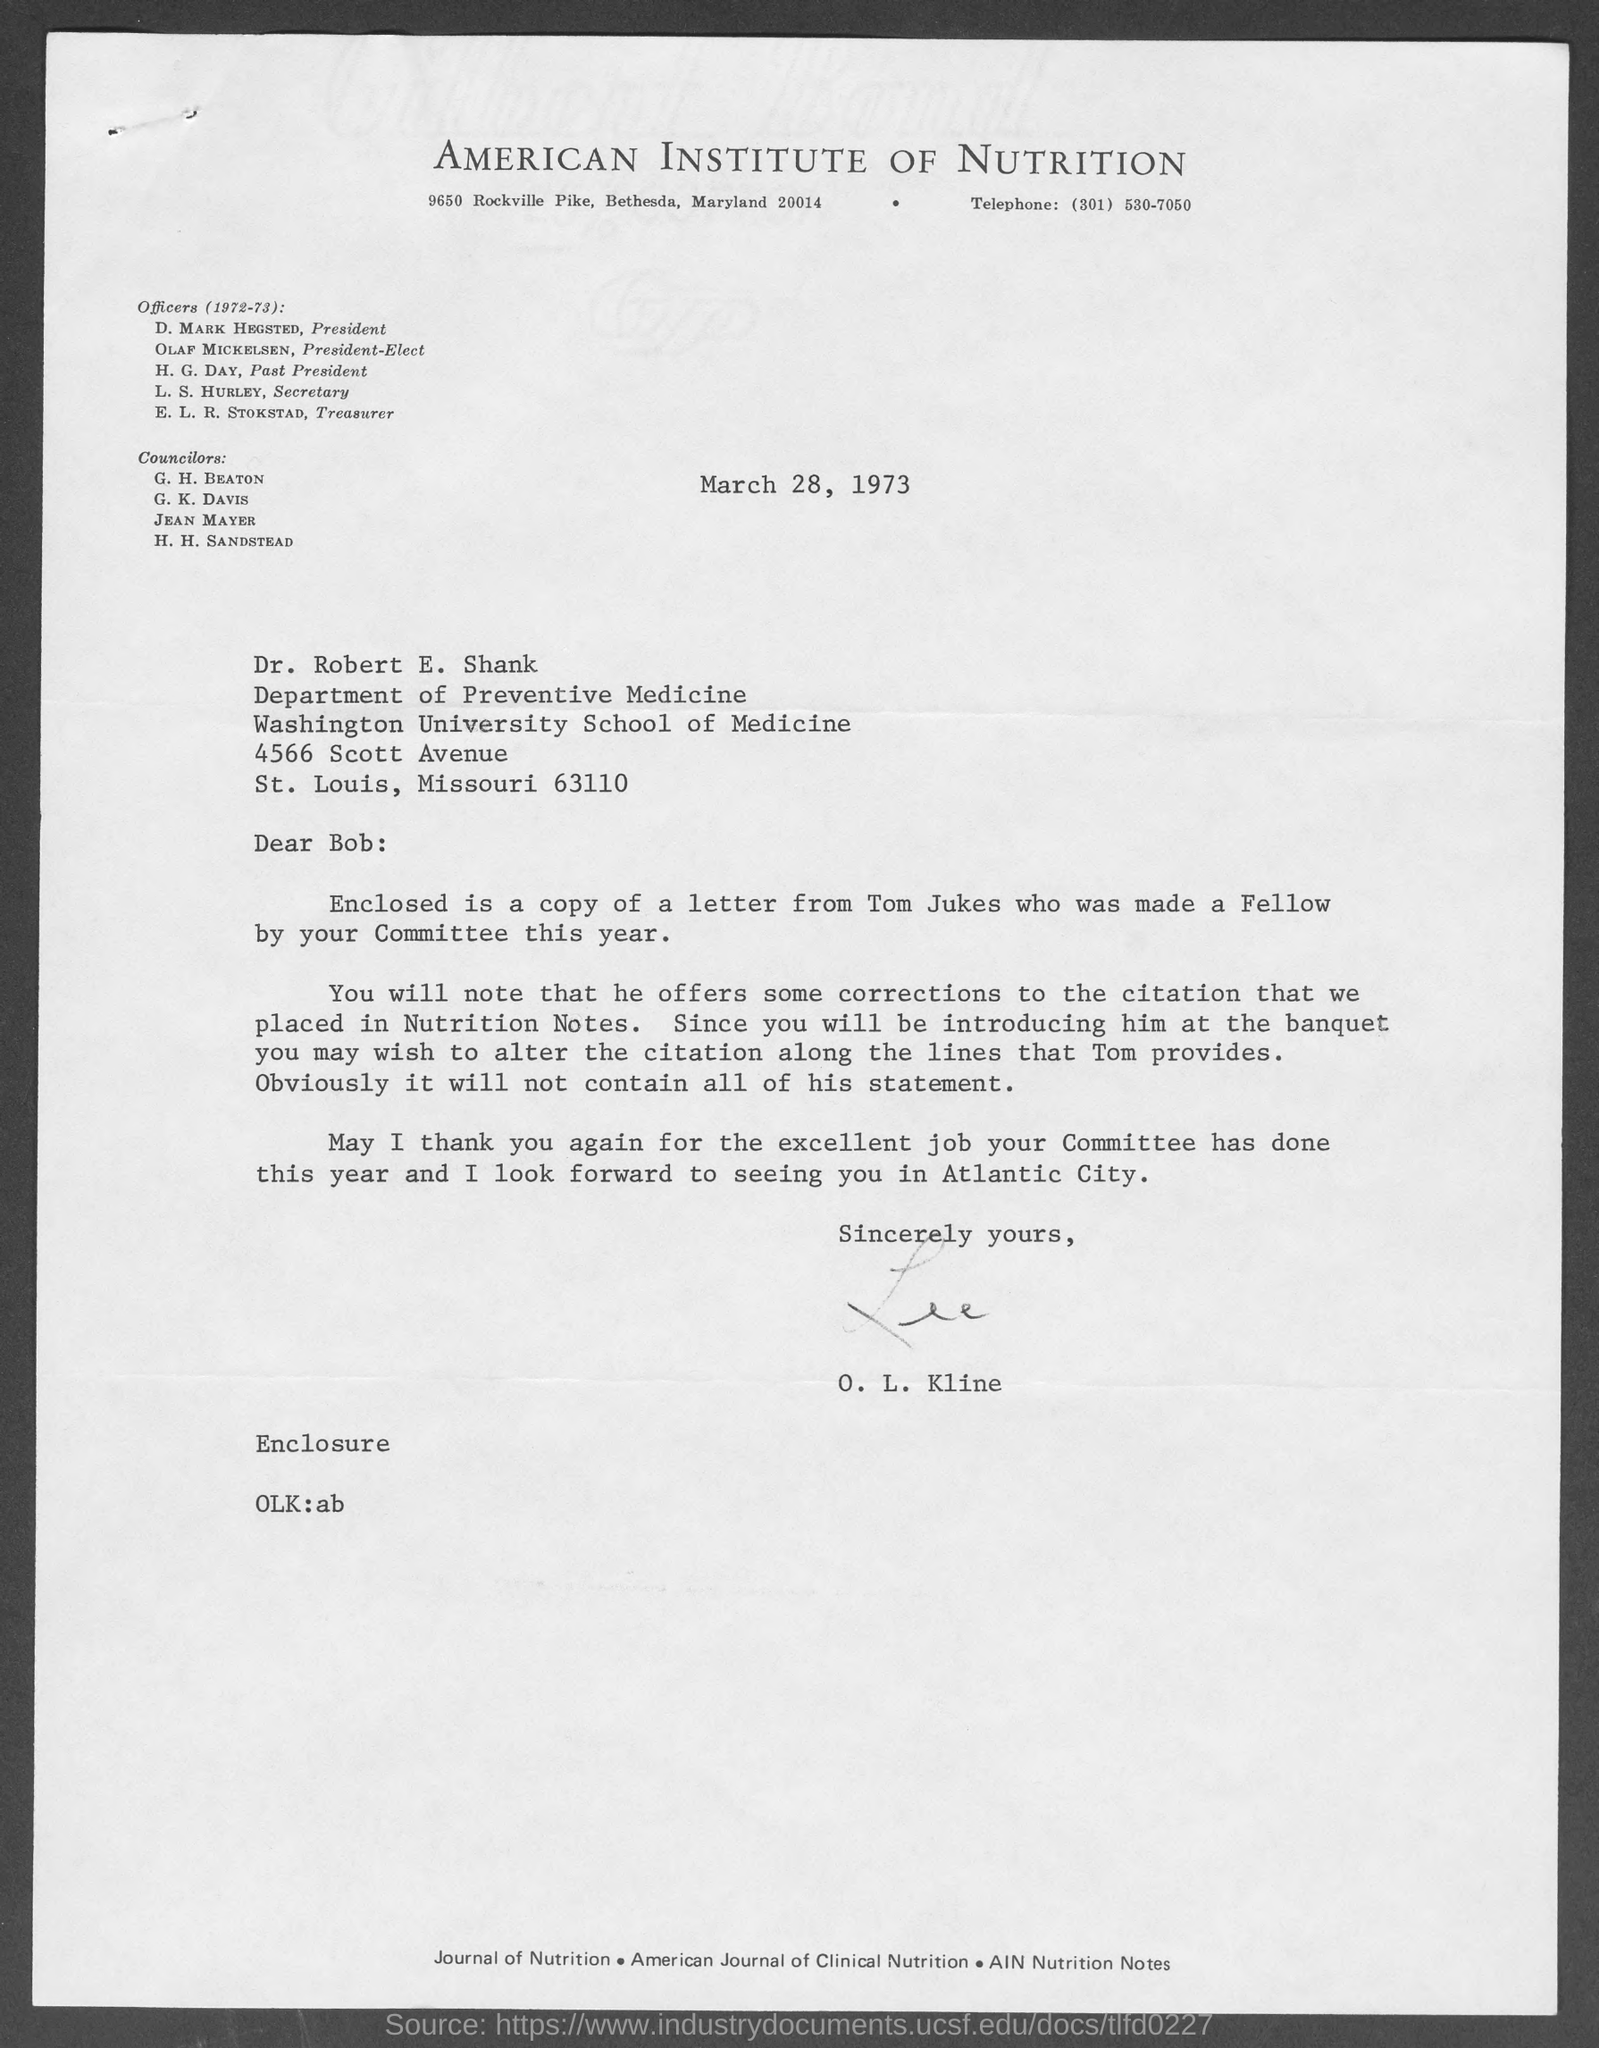Identify some key points in this picture. The president of the American Institute of Nutrition is D. Mark Hegsted. The President-Elect of the American Institute of Nutrition is Olaf Mickelsen. The American Institute of Nutrition has had a past president named H.G. Day. 